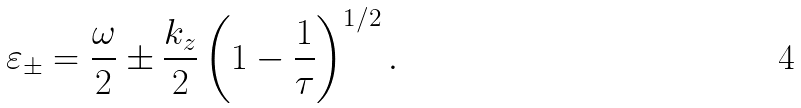<formula> <loc_0><loc_0><loc_500><loc_500>\varepsilon _ { \pm } = \frac { \omega } { 2 } \pm \frac { k _ { z } } 2 \left ( 1 - \frac { 1 } { \tau } \right ) ^ { 1 / 2 } .</formula> 